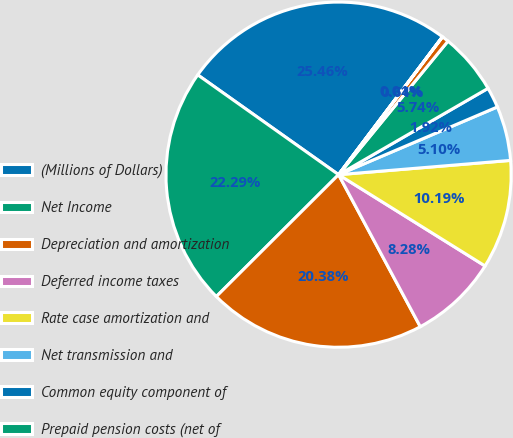<chart> <loc_0><loc_0><loc_500><loc_500><pie_chart><fcel>(Millions of Dollars)<fcel>Net Income<fcel>Depreciation and amortization<fcel>Deferred income taxes<fcel>Rate case amortization and<fcel>Net transmission and<fcel>Common equity component of<fcel>Prepaid pension costs (net of<fcel>Net derivative losses<fcel>Other non-cash items (net)<nl><fcel>25.47%<fcel>22.29%<fcel>20.38%<fcel>8.28%<fcel>10.19%<fcel>5.1%<fcel>1.92%<fcel>5.74%<fcel>0.64%<fcel>0.01%<nl></chart> 